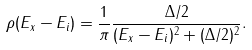Convert formula to latex. <formula><loc_0><loc_0><loc_500><loc_500>\rho ( E _ { x } - E _ { i } ) = \frac { 1 } { \pi } \frac { \Delta / 2 } { ( E _ { x } - E _ { i } ) ^ { 2 } + ( \Delta / 2 ) ^ { 2 } } .</formula> 